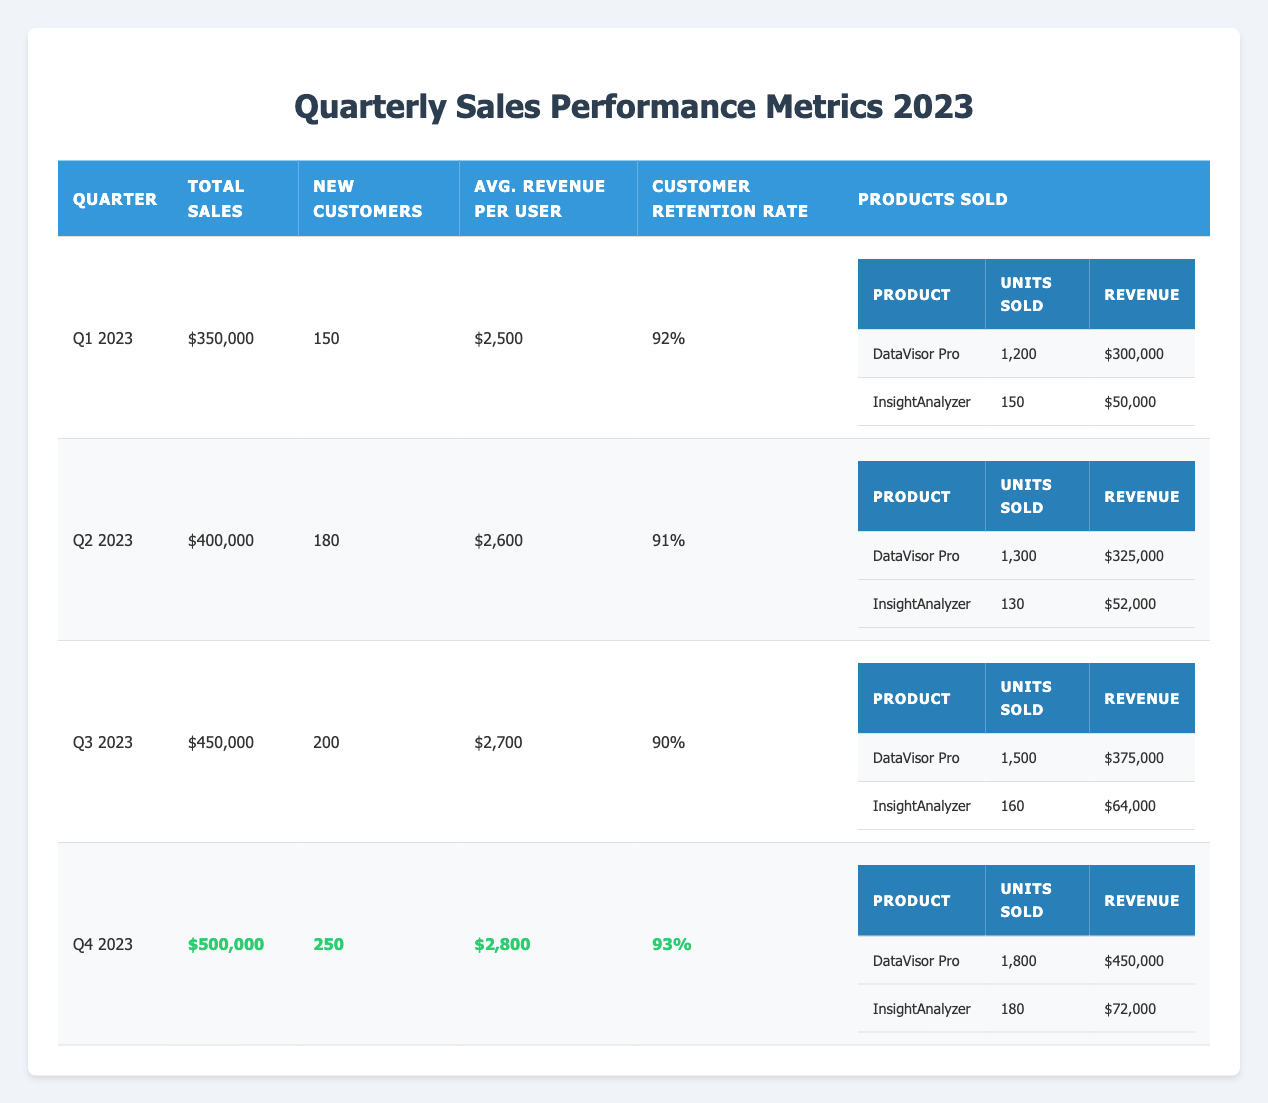What were the total sales in Q3 2023? The total sales for Q3 2023 are listed in the table, specifically under the "Total Sales" column for that quarter. It shows $450,000.
Answer: 450000 How many new customers were acquired in Q2 2023? In the table, the number of new customers acquired for Q2 2023 is shown in the "New Customers" column. It states that 180 new customers were acquired.
Answer: 180 What is the average revenue per user in Q4 2023? The average revenue per user for Q4 2023 can be found in the "Avg. Revenue per User" column. The value is $2,800.
Answer: 2800 What is the percentage increase in total sales from Q1 2023 to Q4 2023? Total sales in Q1 2023 are $350,000, while in Q4 2023 they are $500,000. To find the percentage increase: (500000 - 350000) / 350000 * 100 = 42.86%.
Answer: 42.86% Did the customer retention rate increase from Q2 to Q3 2023? The customer retention rate for Q2 2023 is 91% and for Q3 2023 it is 90%. Since 90% is less than 91%, the retention rate did not increase; it actually decreased.
Answer: No Which product had the highest revenue in Q2 2023? In Q2 2023, the revenue for "DataVisor Pro" is $325,000 and for "InsightAnalyzer" it is $52,000. DataVisor Pro has the highest revenue, as $325,000 is greater than $52,000.
Answer: DataVisor Pro What were the total units sold for InsightAnalyzer across all quarters? The total units sold for InsightAnalyzer are as follows: Q1 (150) + Q2 (130) + Q3 (160) + Q4 (180) = 620 units sold in total.
Answer: 620 How does the average revenue per user in Q3 2023 compare to Q1 2023? The average revenue per user in Q3 2023 is $2,700 and in Q1 2023 is $2,500. To compare, $2,700 is greater than $2,500, indicating an increase.
Answer: Increased What was the retention rate in Q1 2023? The retention rate for Q1 2023 can be found under the "Customer Retention Rate" column for that quarter. It is listed as 92%.
Answer: 92 